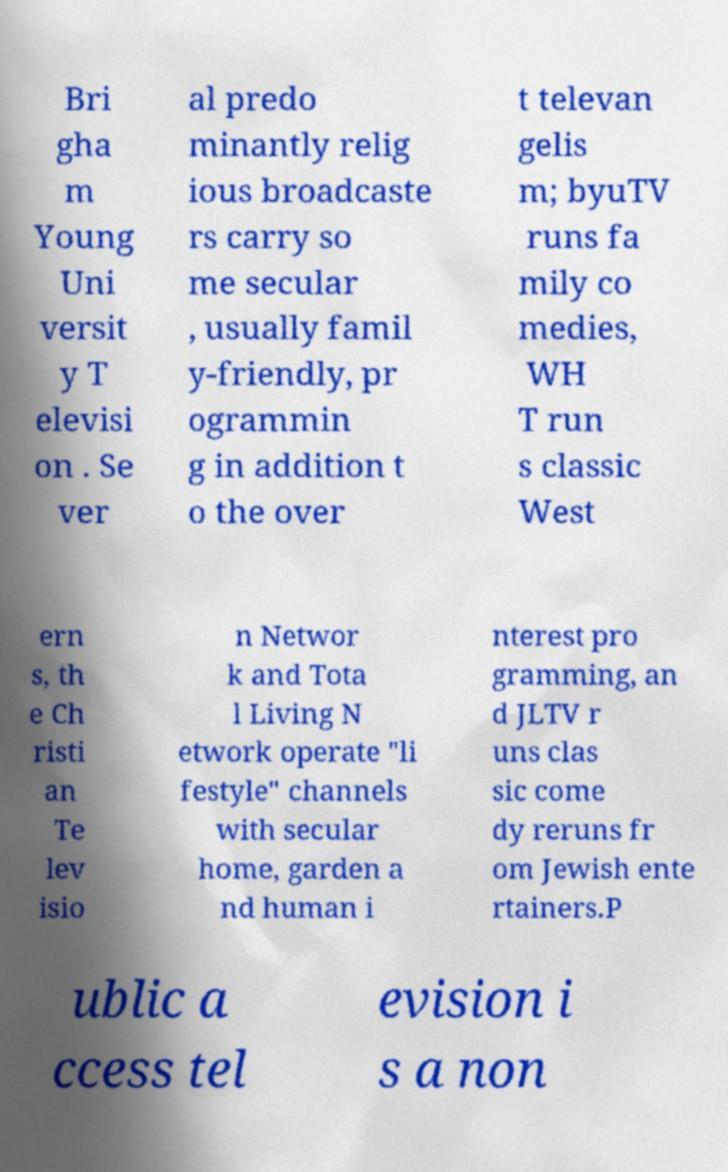Could you assist in decoding the text presented in this image and type it out clearly? Bri gha m Young Uni versit y T elevisi on . Se ver al predo minantly relig ious broadcaste rs carry so me secular , usually famil y-friendly, pr ogrammin g in addition t o the over t televan gelis m; byuTV runs fa mily co medies, WH T run s classic West ern s, th e Ch risti an Te lev isio n Networ k and Tota l Living N etwork operate "li festyle" channels with secular home, garden a nd human i nterest pro gramming, an d JLTV r uns clas sic come dy reruns fr om Jewish ente rtainers.P ublic a ccess tel evision i s a non 